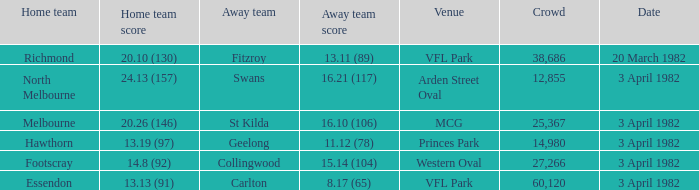What was the point tally for north melbourne's home team? 24.13 (157). 